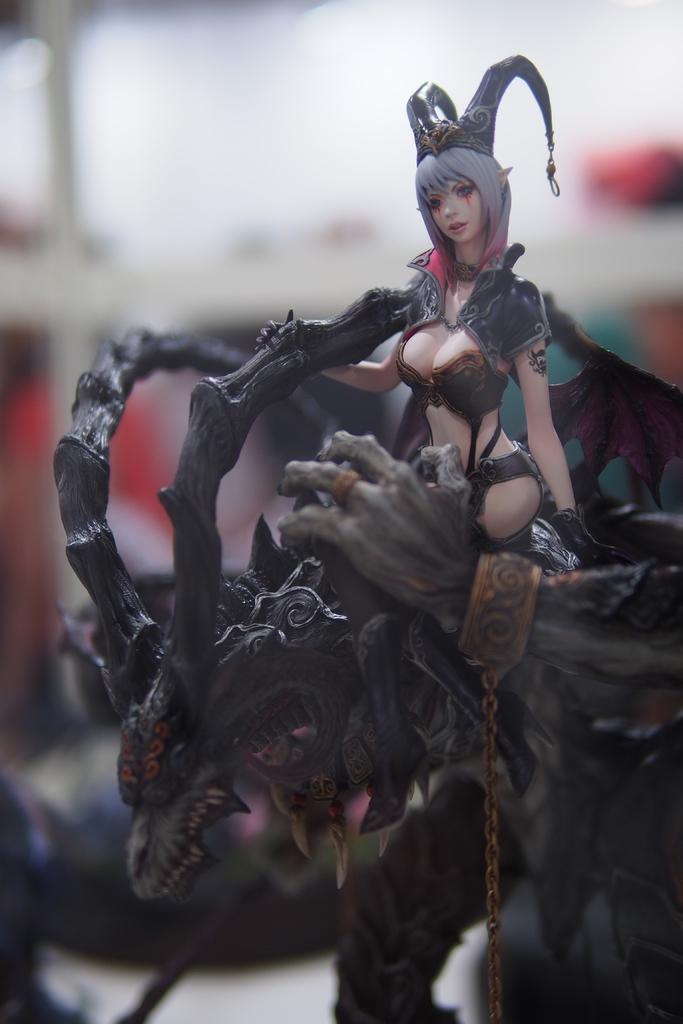Can you describe this image briefly? In this image I can see a toy sitting on the animal and the animal is in black color. 